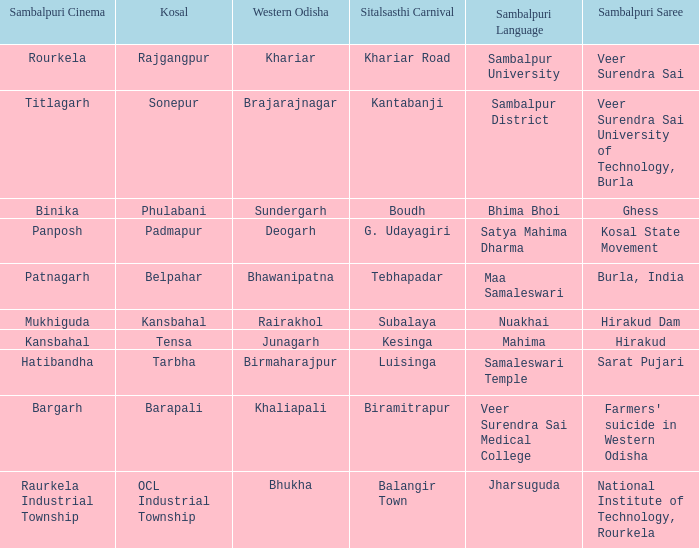What is the Kosal with a balangir town sitalsasthi carnival? OCL Industrial Township. 